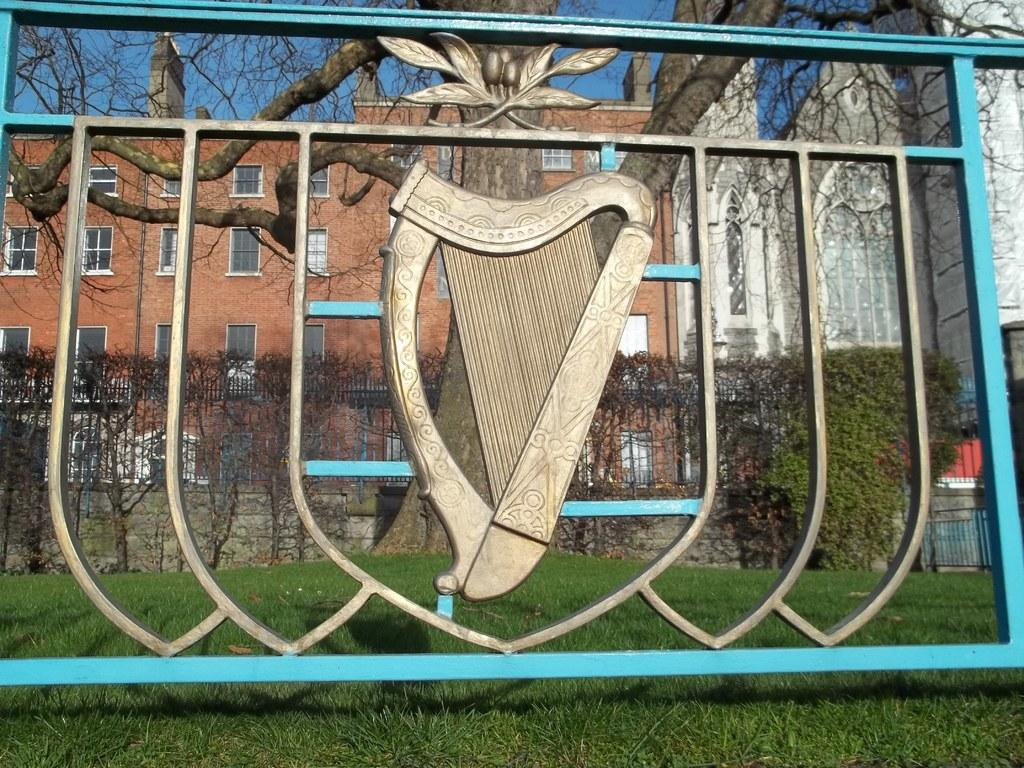What type of barrier can be seen in the image? There is a fence in the image. What type of vegetation is present in the image? There is grass in the image. What other natural elements can be seen in the image? There are trees in the image. What type of structures are visible in the image? There are buildings with windows in the image. What is visible in the background of the image? The sky is visible in the background of the image. Can you see a rake being used to clean the grass in the image? There is no rake present in the image, and no one is using a rake to clean the grass. What thrilling activity is taking place in the image? There is no thrilling activity depicted in the image; it shows a fence, grass, trees, buildings, and the sky. 